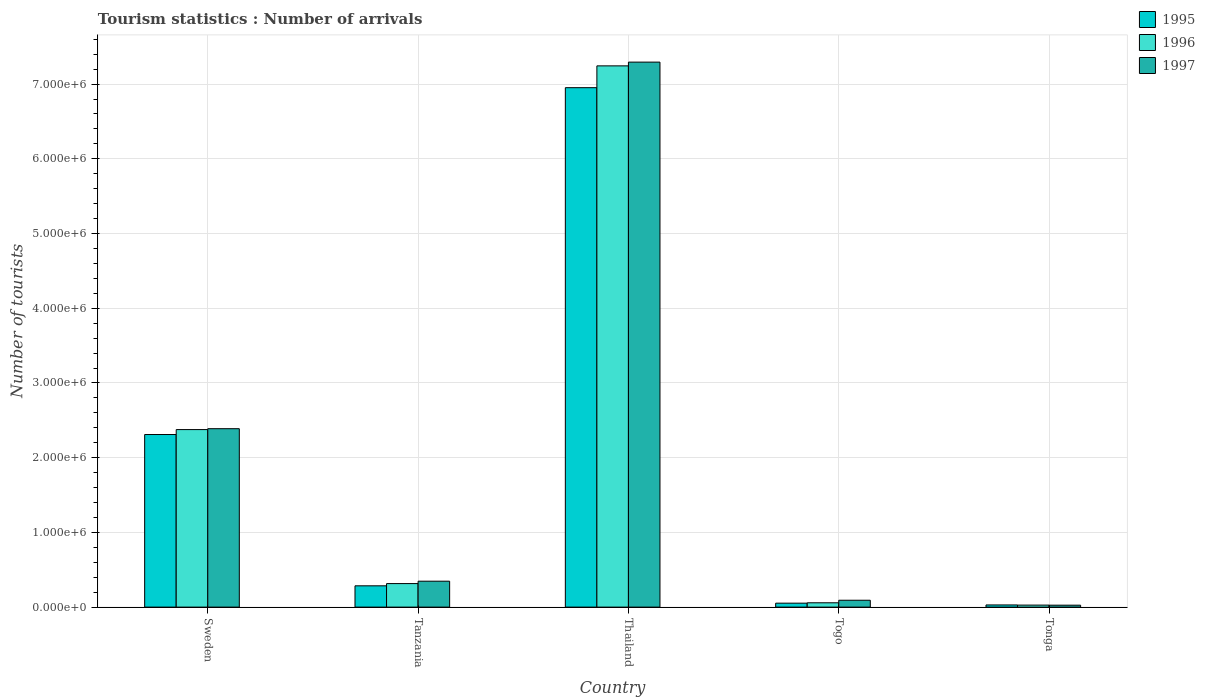How many groups of bars are there?
Your answer should be compact. 5. Are the number of bars on each tick of the X-axis equal?
Offer a very short reply. Yes. What is the label of the 4th group of bars from the left?
Ensure brevity in your answer.  Togo. In how many cases, is the number of bars for a given country not equal to the number of legend labels?
Provide a short and direct response. 0. What is the number of tourist arrivals in 1996 in Thailand?
Make the answer very short. 7.24e+06. Across all countries, what is the maximum number of tourist arrivals in 1995?
Ensure brevity in your answer.  6.95e+06. Across all countries, what is the minimum number of tourist arrivals in 1995?
Provide a short and direct response. 2.90e+04. In which country was the number of tourist arrivals in 1995 maximum?
Keep it short and to the point. Thailand. In which country was the number of tourist arrivals in 1996 minimum?
Offer a very short reply. Tonga. What is the total number of tourist arrivals in 1997 in the graph?
Your response must be concise. 1.01e+07. What is the difference between the number of tourist arrivals in 1997 in Thailand and that in Tonga?
Give a very brief answer. 7.27e+06. What is the difference between the number of tourist arrivals in 1997 in Tonga and the number of tourist arrivals in 1996 in Thailand?
Your answer should be compact. -7.22e+06. What is the average number of tourist arrivals in 1995 per country?
Give a very brief answer. 1.93e+06. What is the difference between the number of tourist arrivals of/in 1997 and number of tourist arrivals of/in 1995 in Togo?
Your answer should be compact. 3.90e+04. In how many countries, is the number of tourist arrivals in 1996 greater than 5200000?
Provide a short and direct response. 1. What is the ratio of the number of tourist arrivals in 1997 in Togo to that in Tonga?
Give a very brief answer. 3.54. Is the number of tourist arrivals in 1995 in Sweden less than that in Tonga?
Give a very brief answer. No. Is the difference between the number of tourist arrivals in 1997 in Tanzania and Thailand greater than the difference between the number of tourist arrivals in 1995 in Tanzania and Thailand?
Your response must be concise. No. What is the difference between the highest and the second highest number of tourist arrivals in 1995?
Your answer should be compact. 6.67e+06. What is the difference between the highest and the lowest number of tourist arrivals in 1997?
Offer a very short reply. 7.27e+06. What does the 1st bar from the left in Togo represents?
Offer a terse response. 1995. What does the 2nd bar from the right in Thailand represents?
Provide a succinct answer. 1996. Is it the case that in every country, the sum of the number of tourist arrivals in 1995 and number of tourist arrivals in 1997 is greater than the number of tourist arrivals in 1996?
Offer a terse response. Yes. How many bars are there?
Your answer should be compact. 15. Are all the bars in the graph horizontal?
Your answer should be compact. No. What is the difference between two consecutive major ticks on the Y-axis?
Your answer should be compact. 1.00e+06. Does the graph contain any zero values?
Provide a succinct answer. No. Where does the legend appear in the graph?
Provide a succinct answer. Top right. What is the title of the graph?
Ensure brevity in your answer.  Tourism statistics : Number of arrivals. Does "1984" appear as one of the legend labels in the graph?
Keep it short and to the point. No. What is the label or title of the X-axis?
Your response must be concise. Country. What is the label or title of the Y-axis?
Provide a short and direct response. Number of tourists. What is the Number of tourists of 1995 in Sweden?
Your answer should be very brief. 2.31e+06. What is the Number of tourists in 1996 in Sweden?
Keep it short and to the point. 2.38e+06. What is the Number of tourists of 1997 in Sweden?
Offer a very short reply. 2.39e+06. What is the Number of tourists in 1995 in Tanzania?
Your answer should be very brief. 2.85e+05. What is the Number of tourists in 1996 in Tanzania?
Your response must be concise. 3.15e+05. What is the Number of tourists in 1997 in Tanzania?
Offer a very short reply. 3.47e+05. What is the Number of tourists in 1995 in Thailand?
Offer a very short reply. 6.95e+06. What is the Number of tourists in 1996 in Thailand?
Give a very brief answer. 7.24e+06. What is the Number of tourists in 1997 in Thailand?
Provide a short and direct response. 7.29e+06. What is the Number of tourists of 1995 in Togo?
Provide a short and direct response. 5.30e+04. What is the Number of tourists of 1996 in Togo?
Offer a very short reply. 5.80e+04. What is the Number of tourists of 1997 in Togo?
Give a very brief answer. 9.20e+04. What is the Number of tourists of 1995 in Tonga?
Make the answer very short. 2.90e+04. What is the Number of tourists in 1996 in Tonga?
Keep it short and to the point. 2.70e+04. What is the Number of tourists in 1997 in Tonga?
Make the answer very short. 2.60e+04. Across all countries, what is the maximum Number of tourists in 1995?
Give a very brief answer. 6.95e+06. Across all countries, what is the maximum Number of tourists in 1996?
Your answer should be very brief. 7.24e+06. Across all countries, what is the maximum Number of tourists of 1997?
Ensure brevity in your answer.  7.29e+06. Across all countries, what is the minimum Number of tourists in 1995?
Your response must be concise. 2.90e+04. Across all countries, what is the minimum Number of tourists of 1996?
Make the answer very short. 2.70e+04. Across all countries, what is the minimum Number of tourists of 1997?
Offer a terse response. 2.60e+04. What is the total Number of tourists in 1995 in the graph?
Make the answer very short. 9.63e+06. What is the total Number of tourists in 1996 in the graph?
Keep it short and to the point. 1.00e+07. What is the total Number of tourists in 1997 in the graph?
Your answer should be very brief. 1.01e+07. What is the difference between the Number of tourists in 1995 in Sweden and that in Tanzania?
Give a very brief answer. 2.02e+06. What is the difference between the Number of tourists in 1996 in Sweden and that in Tanzania?
Ensure brevity in your answer.  2.06e+06. What is the difference between the Number of tourists in 1997 in Sweden and that in Tanzania?
Your response must be concise. 2.04e+06. What is the difference between the Number of tourists in 1995 in Sweden and that in Thailand?
Give a very brief answer. -4.64e+06. What is the difference between the Number of tourists of 1996 in Sweden and that in Thailand?
Provide a succinct answer. -4.87e+06. What is the difference between the Number of tourists in 1997 in Sweden and that in Thailand?
Make the answer very short. -4.91e+06. What is the difference between the Number of tourists in 1995 in Sweden and that in Togo?
Your answer should be very brief. 2.26e+06. What is the difference between the Number of tourists of 1996 in Sweden and that in Togo?
Provide a short and direct response. 2.32e+06. What is the difference between the Number of tourists in 1997 in Sweden and that in Togo?
Your answer should be very brief. 2.30e+06. What is the difference between the Number of tourists in 1995 in Sweden and that in Tonga?
Your response must be concise. 2.28e+06. What is the difference between the Number of tourists in 1996 in Sweden and that in Tonga?
Ensure brevity in your answer.  2.35e+06. What is the difference between the Number of tourists of 1997 in Sweden and that in Tonga?
Your response must be concise. 2.36e+06. What is the difference between the Number of tourists of 1995 in Tanzania and that in Thailand?
Make the answer very short. -6.67e+06. What is the difference between the Number of tourists in 1996 in Tanzania and that in Thailand?
Provide a short and direct response. -6.93e+06. What is the difference between the Number of tourists of 1997 in Tanzania and that in Thailand?
Your answer should be very brief. -6.95e+06. What is the difference between the Number of tourists of 1995 in Tanzania and that in Togo?
Make the answer very short. 2.32e+05. What is the difference between the Number of tourists in 1996 in Tanzania and that in Togo?
Give a very brief answer. 2.57e+05. What is the difference between the Number of tourists of 1997 in Tanzania and that in Togo?
Provide a short and direct response. 2.55e+05. What is the difference between the Number of tourists in 1995 in Tanzania and that in Tonga?
Make the answer very short. 2.56e+05. What is the difference between the Number of tourists in 1996 in Tanzania and that in Tonga?
Provide a succinct answer. 2.88e+05. What is the difference between the Number of tourists of 1997 in Tanzania and that in Tonga?
Your response must be concise. 3.21e+05. What is the difference between the Number of tourists of 1995 in Thailand and that in Togo?
Offer a terse response. 6.90e+06. What is the difference between the Number of tourists in 1996 in Thailand and that in Togo?
Give a very brief answer. 7.19e+06. What is the difference between the Number of tourists of 1997 in Thailand and that in Togo?
Offer a terse response. 7.20e+06. What is the difference between the Number of tourists of 1995 in Thailand and that in Tonga?
Provide a succinct answer. 6.92e+06. What is the difference between the Number of tourists in 1996 in Thailand and that in Tonga?
Make the answer very short. 7.22e+06. What is the difference between the Number of tourists in 1997 in Thailand and that in Tonga?
Give a very brief answer. 7.27e+06. What is the difference between the Number of tourists in 1995 in Togo and that in Tonga?
Provide a succinct answer. 2.40e+04. What is the difference between the Number of tourists of 1996 in Togo and that in Tonga?
Give a very brief answer. 3.10e+04. What is the difference between the Number of tourists of 1997 in Togo and that in Tonga?
Keep it short and to the point. 6.60e+04. What is the difference between the Number of tourists in 1995 in Sweden and the Number of tourists in 1996 in Tanzania?
Keep it short and to the point. 2.00e+06. What is the difference between the Number of tourists of 1995 in Sweden and the Number of tourists of 1997 in Tanzania?
Offer a very short reply. 1.96e+06. What is the difference between the Number of tourists in 1996 in Sweden and the Number of tourists in 1997 in Tanzania?
Provide a succinct answer. 2.03e+06. What is the difference between the Number of tourists in 1995 in Sweden and the Number of tourists in 1996 in Thailand?
Give a very brief answer. -4.93e+06. What is the difference between the Number of tourists of 1995 in Sweden and the Number of tourists of 1997 in Thailand?
Offer a terse response. -4.98e+06. What is the difference between the Number of tourists in 1996 in Sweden and the Number of tourists in 1997 in Thailand?
Your response must be concise. -4.92e+06. What is the difference between the Number of tourists in 1995 in Sweden and the Number of tourists in 1996 in Togo?
Offer a terse response. 2.25e+06. What is the difference between the Number of tourists of 1995 in Sweden and the Number of tourists of 1997 in Togo?
Provide a short and direct response. 2.22e+06. What is the difference between the Number of tourists in 1996 in Sweden and the Number of tourists in 1997 in Togo?
Give a very brief answer. 2.28e+06. What is the difference between the Number of tourists of 1995 in Sweden and the Number of tourists of 1996 in Tonga?
Give a very brief answer. 2.28e+06. What is the difference between the Number of tourists of 1995 in Sweden and the Number of tourists of 1997 in Tonga?
Your response must be concise. 2.28e+06. What is the difference between the Number of tourists in 1996 in Sweden and the Number of tourists in 1997 in Tonga?
Provide a succinct answer. 2.35e+06. What is the difference between the Number of tourists of 1995 in Tanzania and the Number of tourists of 1996 in Thailand?
Make the answer very short. -6.96e+06. What is the difference between the Number of tourists in 1995 in Tanzania and the Number of tourists in 1997 in Thailand?
Provide a succinct answer. -7.01e+06. What is the difference between the Number of tourists in 1996 in Tanzania and the Number of tourists in 1997 in Thailand?
Your response must be concise. -6.98e+06. What is the difference between the Number of tourists in 1995 in Tanzania and the Number of tourists in 1996 in Togo?
Keep it short and to the point. 2.27e+05. What is the difference between the Number of tourists of 1995 in Tanzania and the Number of tourists of 1997 in Togo?
Provide a short and direct response. 1.93e+05. What is the difference between the Number of tourists of 1996 in Tanzania and the Number of tourists of 1997 in Togo?
Give a very brief answer. 2.23e+05. What is the difference between the Number of tourists of 1995 in Tanzania and the Number of tourists of 1996 in Tonga?
Make the answer very short. 2.58e+05. What is the difference between the Number of tourists of 1995 in Tanzania and the Number of tourists of 1997 in Tonga?
Your answer should be very brief. 2.59e+05. What is the difference between the Number of tourists of 1996 in Tanzania and the Number of tourists of 1997 in Tonga?
Your answer should be very brief. 2.89e+05. What is the difference between the Number of tourists in 1995 in Thailand and the Number of tourists in 1996 in Togo?
Your answer should be very brief. 6.89e+06. What is the difference between the Number of tourists of 1995 in Thailand and the Number of tourists of 1997 in Togo?
Make the answer very short. 6.86e+06. What is the difference between the Number of tourists of 1996 in Thailand and the Number of tourists of 1997 in Togo?
Ensure brevity in your answer.  7.15e+06. What is the difference between the Number of tourists in 1995 in Thailand and the Number of tourists in 1996 in Tonga?
Ensure brevity in your answer.  6.92e+06. What is the difference between the Number of tourists of 1995 in Thailand and the Number of tourists of 1997 in Tonga?
Your response must be concise. 6.93e+06. What is the difference between the Number of tourists of 1996 in Thailand and the Number of tourists of 1997 in Tonga?
Your answer should be compact. 7.22e+06. What is the difference between the Number of tourists of 1995 in Togo and the Number of tourists of 1996 in Tonga?
Offer a very short reply. 2.60e+04. What is the difference between the Number of tourists in 1995 in Togo and the Number of tourists in 1997 in Tonga?
Your answer should be very brief. 2.70e+04. What is the difference between the Number of tourists of 1996 in Togo and the Number of tourists of 1997 in Tonga?
Give a very brief answer. 3.20e+04. What is the average Number of tourists in 1995 per country?
Keep it short and to the point. 1.93e+06. What is the average Number of tourists in 1996 per country?
Your answer should be compact. 2.00e+06. What is the average Number of tourists in 1997 per country?
Offer a very short reply. 2.03e+06. What is the difference between the Number of tourists of 1995 and Number of tourists of 1996 in Sweden?
Provide a succinct answer. -6.60e+04. What is the difference between the Number of tourists in 1995 and Number of tourists in 1997 in Sweden?
Offer a very short reply. -7.80e+04. What is the difference between the Number of tourists in 1996 and Number of tourists in 1997 in Sweden?
Your answer should be very brief. -1.20e+04. What is the difference between the Number of tourists of 1995 and Number of tourists of 1997 in Tanzania?
Provide a short and direct response. -6.20e+04. What is the difference between the Number of tourists in 1996 and Number of tourists in 1997 in Tanzania?
Provide a short and direct response. -3.20e+04. What is the difference between the Number of tourists in 1995 and Number of tourists in 1996 in Thailand?
Offer a very short reply. -2.92e+05. What is the difference between the Number of tourists of 1995 and Number of tourists of 1997 in Thailand?
Ensure brevity in your answer.  -3.42e+05. What is the difference between the Number of tourists in 1995 and Number of tourists in 1996 in Togo?
Keep it short and to the point. -5000. What is the difference between the Number of tourists of 1995 and Number of tourists of 1997 in Togo?
Offer a very short reply. -3.90e+04. What is the difference between the Number of tourists in 1996 and Number of tourists in 1997 in Togo?
Your answer should be very brief. -3.40e+04. What is the difference between the Number of tourists of 1995 and Number of tourists of 1996 in Tonga?
Your answer should be compact. 2000. What is the difference between the Number of tourists of 1995 and Number of tourists of 1997 in Tonga?
Your answer should be very brief. 3000. What is the ratio of the Number of tourists in 1995 in Sweden to that in Tanzania?
Your answer should be compact. 8.11. What is the ratio of the Number of tourists of 1996 in Sweden to that in Tanzania?
Provide a succinct answer. 7.54. What is the ratio of the Number of tourists of 1997 in Sweden to that in Tanzania?
Ensure brevity in your answer.  6.88. What is the ratio of the Number of tourists of 1995 in Sweden to that in Thailand?
Offer a terse response. 0.33. What is the ratio of the Number of tourists in 1996 in Sweden to that in Thailand?
Keep it short and to the point. 0.33. What is the ratio of the Number of tourists of 1997 in Sweden to that in Thailand?
Make the answer very short. 0.33. What is the ratio of the Number of tourists of 1995 in Sweden to that in Togo?
Keep it short and to the point. 43.58. What is the ratio of the Number of tourists in 1996 in Sweden to that in Togo?
Ensure brevity in your answer.  40.97. What is the ratio of the Number of tourists in 1997 in Sweden to that in Togo?
Your response must be concise. 25.96. What is the ratio of the Number of tourists in 1995 in Sweden to that in Tonga?
Your response must be concise. 79.66. What is the ratio of the Number of tourists in 1997 in Sweden to that in Tonga?
Make the answer very short. 91.85. What is the ratio of the Number of tourists in 1995 in Tanzania to that in Thailand?
Offer a very short reply. 0.04. What is the ratio of the Number of tourists in 1996 in Tanzania to that in Thailand?
Ensure brevity in your answer.  0.04. What is the ratio of the Number of tourists of 1997 in Tanzania to that in Thailand?
Your answer should be very brief. 0.05. What is the ratio of the Number of tourists of 1995 in Tanzania to that in Togo?
Your answer should be compact. 5.38. What is the ratio of the Number of tourists of 1996 in Tanzania to that in Togo?
Offer a very short reply. 5.43. What is the ratio of the Number of tourists in 1997 in Tanzania to that in Togo?
Provide a succinct answer. 3.77. What is the ratio of the Number of tourists of 1995 in Tanzania to that in Tonga?
Keep it short and to the point. 9.83. What is the ratio of the Number of tourists of 1996 in Tanzania to that in Tonga?
Offer a very short reply. 11.67. What is the ratio of the Number of tourists of 1997 in Tanzania to that in Tonga?
Your response must be concise. 13.35. What is the ratio of the Number of tourists in 1995 in Thailand to that in Togo?
Offer a terse response. 131.17. What is the ratio of the Number of tourists in 1996 in Thailand to that in Togo?
Keep it short and to the point. 124.9. What is the ratio of the Number of tourists in 1997 in Thailand to that in Togo?
Keep it short and to the point. 79.28. What is the ratio of the Number of tourists of 1995 in Thailand to that in Tonga?
Ensure brevity in your answer.  239.72. What is the ratio of the Number of tourists of 1996 in Thailand to that in Tonga?
Your answer should be very brief. 268.3. What is the ratio of the Number of tourists in 1997 in Thailand to that in Tonga?
Offer a terse response. 280.54. What is the ratio of the Number of tourists of 1995 in Togo to that in Tonga?
Offer a very short reply. 1.83. What is the ratio of the Number of tourists in 1996 in Togo to that in Tonga?
Keep it short and to the point. 2.15. What is the ratio of the Number of tourists in 1997 in Togo to that in Tonga?
Your answer should be compact. 3.54. What is the difference between the highest and the second highest Number of tourists of 1995?
Give a very brief answer. 4.64e+06. What is the difference between the highest and the second highest Number of tourists in 1996?
Your response must be concise. 4.87e+06. What is the difference between the highest and the second highest Number of tourists in 1997?
Keep it short and to the point. 4.91e+06. What is the difference between the highest and the lowest Number of tourists of 1995?
Make the answer very short. 6.92e+06. What is the difference between the highest and the lowest Number of tourists of 1996?
Offer a terse response. 7.22e+06. What is the difference between the highest and the lowest Number of tourists in 1997?
Provide a short and direct response. 7.27e+06. 